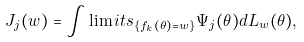Convert formula to latex. <formula><loc_0><loc_0><loc_500><loc_500>J _ { j } ( w ) = \int \lim i t s _ { \{ f _ { k } ( \theta ) = w \} } \Psi _ { j } ( \theta ) d L _ { w } ( \theta ) ,</formula> 